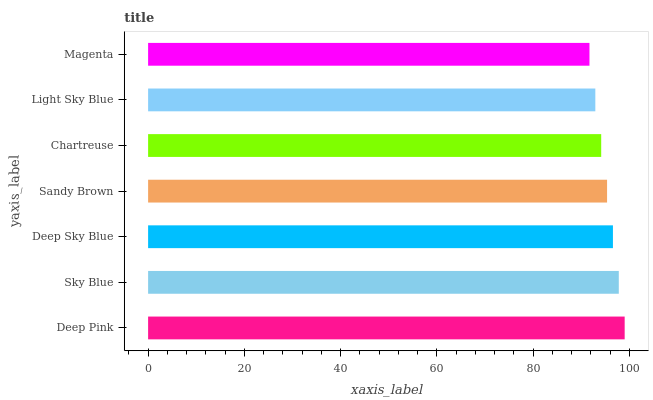Is Magenta the minimum?
Answer yes or no. Yes. Is Deep Pink the maximum?
Answer yes or no. Yes. Is Sky Blue the minimum?
Answer yes or no. No. Is Sky Blue the maximum?
Answer yes or no. No. Is Deep Pink greater than Sky Blue?
Answer yes or no. Yes. Is Sky Blue less than Deep Pink?
Answer yes or no. Yes. Is Sky Blue greater than Deep Pink?
Answer yes or no. No. Is Deep Pink less than Sky Blue?
Answer yes or no. No. Is Sandy Brown the high median?
Answer yes or no. Yes. Is Sandy Brown the low median?
Answer yes or no. Yes. Is Deep Sky Blue the high median?
Answer yes or no. No. Is Deep Sky Blue the low median?
Answer yes or no. No. 